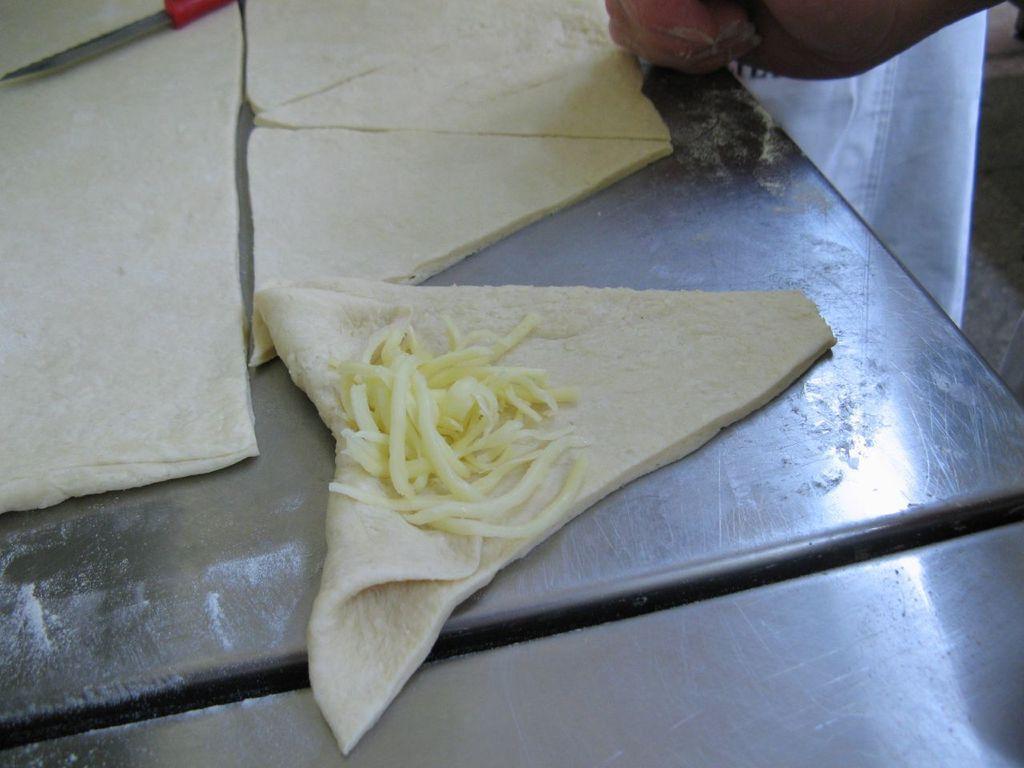Can you describe this image briefly? In this image there is a food item cut into pieces , there is another food item on one of the slice on the table, there is a knife and a person hand. 